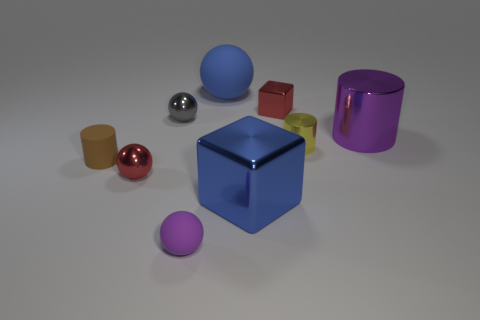Does the large matte sphere have the same color as the big shiny block?
Your answer should be very brief. Yes. Is there a small red object that is in front of the big thing that is right of the blue thing that is in front of the gray metal thing?
Offer a terse response. Yes. How many brown blocks have the same size as the yellow cylinder?
Your answer should be compact. 0. There is a red metal object that is in front of the brown thing; does it have the same size as the cylinder to the left of the tiny purple ball?
Offer a very short reply. Yes. What shape is the tiny metallic thing that is both right of the large metallic block and behind the purple shiny object?
Offer a terse response. Cube. Is there a ball that has the same color as the big metal cylinder?
Your answer should be very brief. Yes. Are there any big purple matte objects?
Provide a short and direct response. No. There is a rubber sphere that is on the left side of the blue matte object; what color is it?
Your answer should be very brief. Purple. Do the yellow object and the matte thing in front of the brown cylinder have the same size?
Your answer should be very brief. Yes. There is a metal object that is behind the yellow thing and in front of the gray object; what is its size?
Provide a succinct answer. Large. 